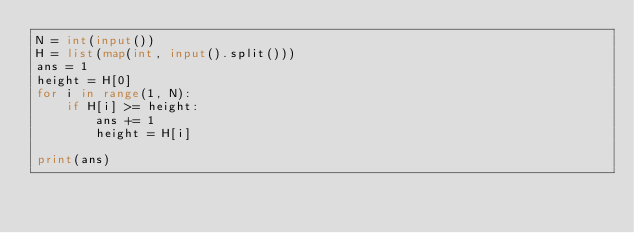<code> <loc_0><loc_0><loc_500><loc_500><_Python_>N = int(input())
H = list(map(int, input().split()))
ans = 1
height = H[0]
for i in range(1, N):
    if H[i] >= height:
        ans += 1
        height = H[i]

print(ans)</code> 